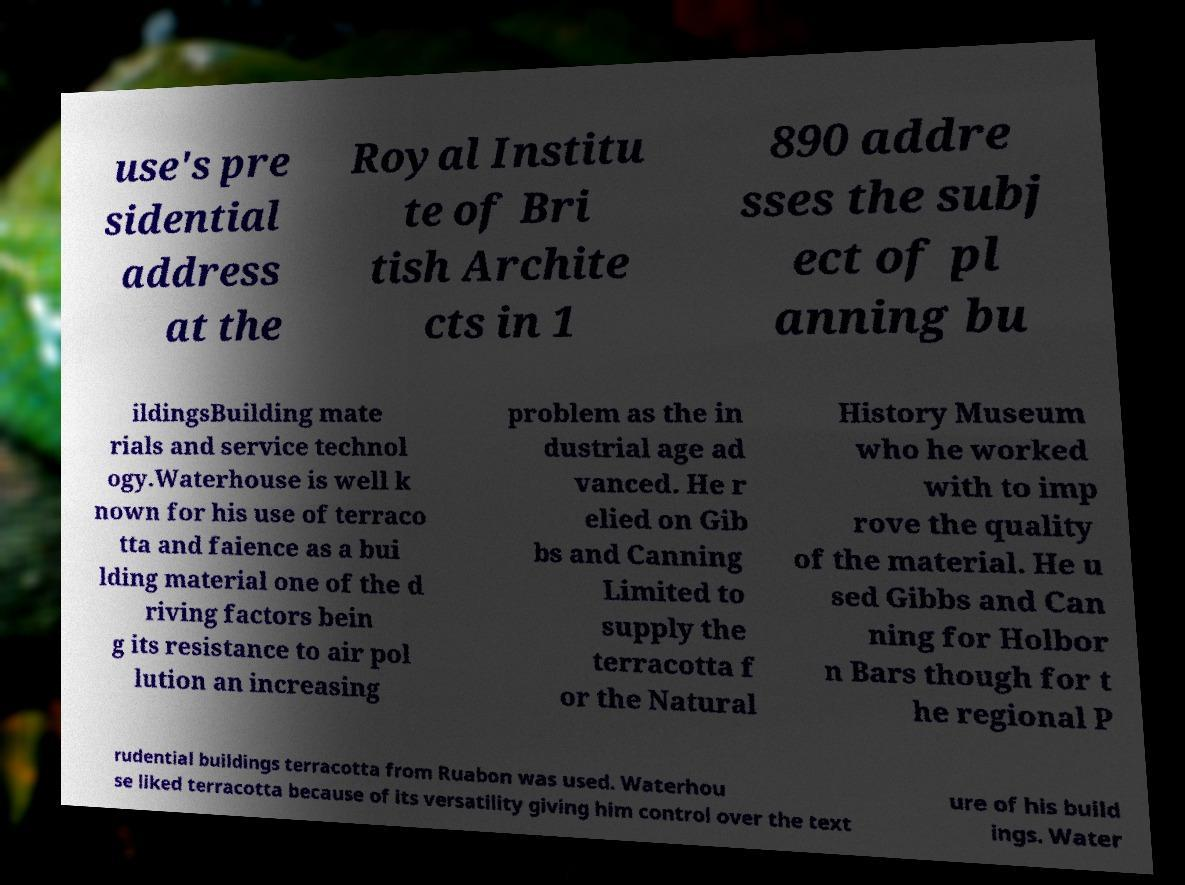Please read and relay the text visible in this image. What does it say? use's pre sidential address at the Royal Institu te of Bri tish Archite cts in 1 890 addre sses the subj ect of pl anning bu ildingsBuilding mate rials and service technol ogy.Waterhouse is well k nown for his use of terraco tta and faience as a bui lding material one of the d riving factors bein g its resistance to air pol lution an increasing problem as the in dustrial age ad vanced. He r elied on Gib bs and Canning Limited to supply the terracotta f or the Natural History Museum who he worked with to imp rove the quality of the material. He u sed Gibbs and Can ning for Holbor n Bars though for t he regional P rudential buildings terracotta from Ruabon was used. Waterhou se liked terracotta because of its versatility giving him control over the text ure of his build ings. Water 